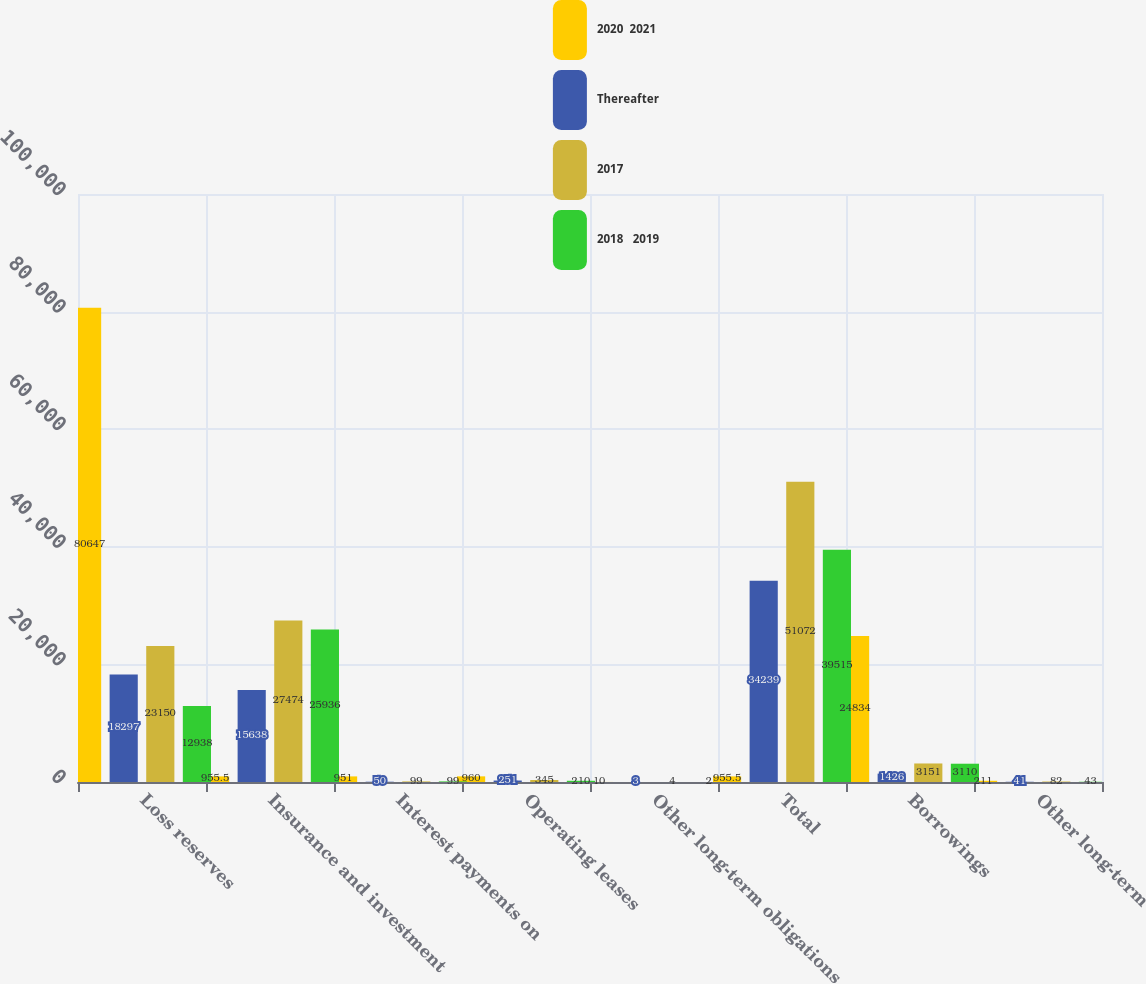Convert chart. <chart><loc_0><loc_0><loc_500><loc_500><stacked_bar_chart><ecel><fcel>Loss reserves<fcel>Insurance and investment<fcel>Interest payments on<fcel>Operating leases<fcel>Other long-term obligations<fcel>Total<fcel>Borrowings<fcel>Other long-term<nl><fcel>2020  2021<fcel>80647<fcel>955.5<fcel>951<fcel>960<fcel>10<fcel>955.5<fcel>24834<fcel>211<nl><fcel>Thereafter<fcel>18297<fcel>15638<fcel>50<fcel>251<fcel>3<fcel>34239<fcel>1426<fcel>41<nl><fcel>2017<fcel>23150<fcel>27474<fcel>99<fcel>345<fcel>4<fcel>51072<fcel>3151<fcel>82<nl><fcel>2018   2019<fcel>12938<fcel>25936<fcel>99<fcel>210<fcel>2<fcel>39515<fcel>3110<fcel>43<nl></chart> 